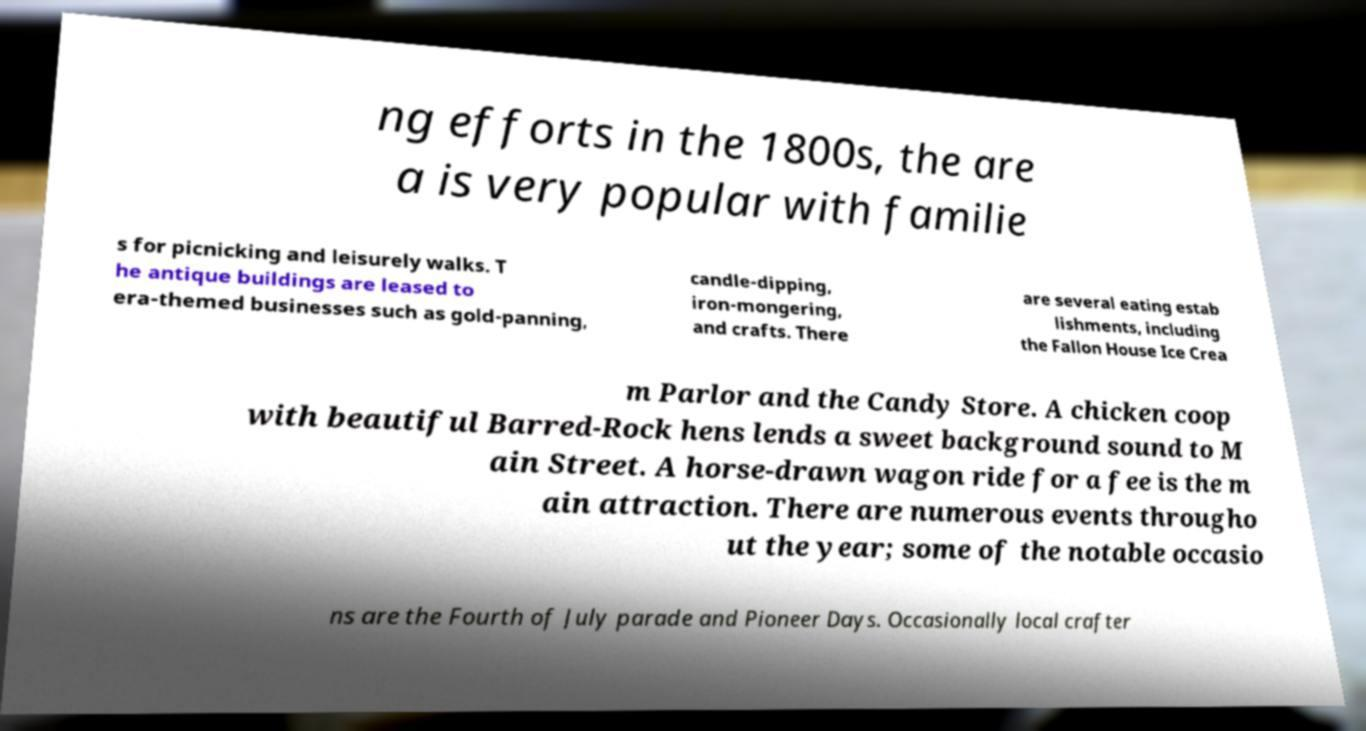Please read and relay the text visible in this image. What does it say? ng efforts in the 1800s, the are a is very popular with familie s for picnicking and leisurely walks. T he antique buildings are leased to era-themed businesses such as gold-panning, candle-dipping, iron-mongering, and crafts. There are several eating estab lishments, including the Fallon House Ice Crea m Parlor and the Candy Store. A chicken coop with beautiful Barred-Rock hens lends a sweet background sound to M ain Street. A horse-drawn wagon ride for a fee is the m ain attraction. There are numerous events througho ut the year; some of the notable occasio ns are the Fourth of July parade and Pioneer Days. Occasionally local crafter 